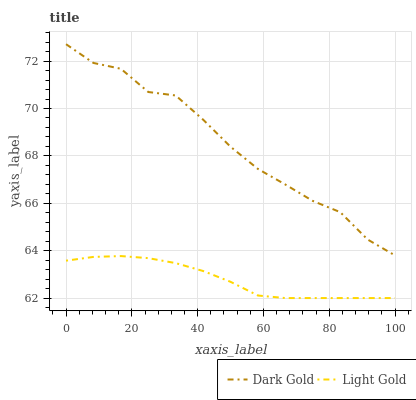Does Light Gold have the minimum area under the curve?
Answer yes or no. Yes. Does Dark Gold have the maximum area under the curve?
Answer yes or no. Yes. Does Dark Gold have the minimum area under the curve?
Answer yes or no. No. Is Light Gold the smoothest?
Answer yes or no. Yes. Is Dark Gold the roughest?
Answer yes or no. Yes. Is Dark Gold the smoothest?
Answer yes or no. No. Does Dark Gold have the lowest value?
Answer yes or no. No. Is Light Gold less than Dark Gold?
Answer yes or no. Yes. Is Dark Gold greater than Light Gold?
Answer yes or no. Yes. Does Light Gold intersect Dark Gold?
Answer yes or no. No. 